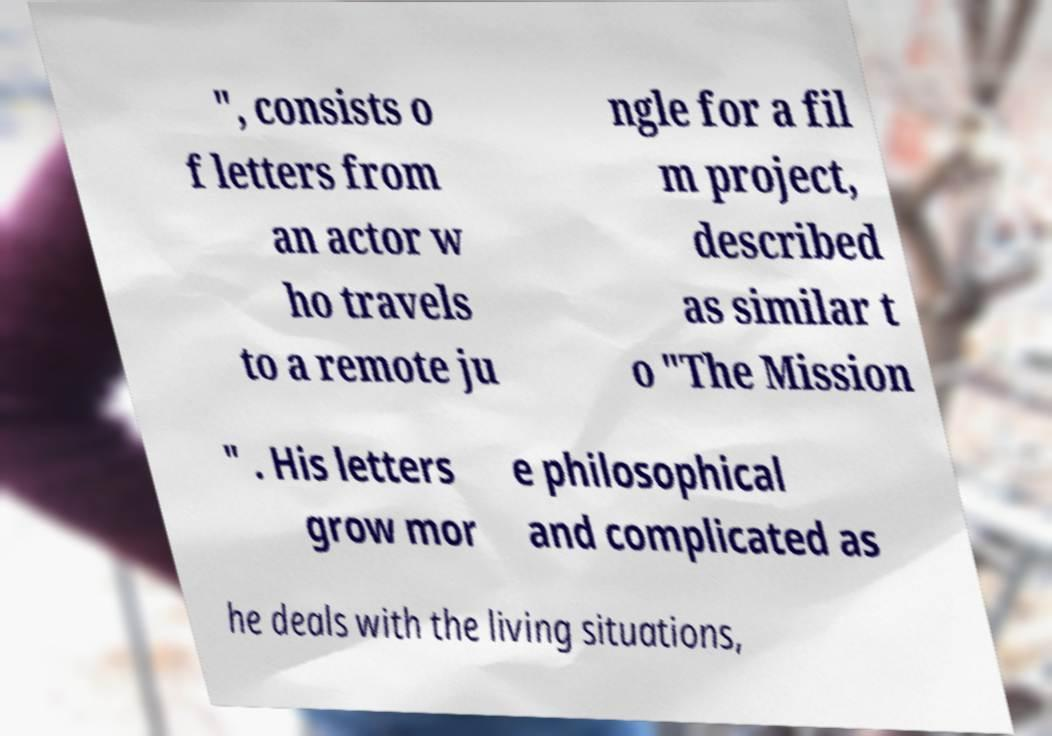Please read and relay the text visible in this image. What does it say? ", consists o f letters from an actor w ho travels to a remote ju ngle for a fil m project, described as similar t o "The Mission " . His letters grow mor e philosophical and complicated as he deals with the living situations, 